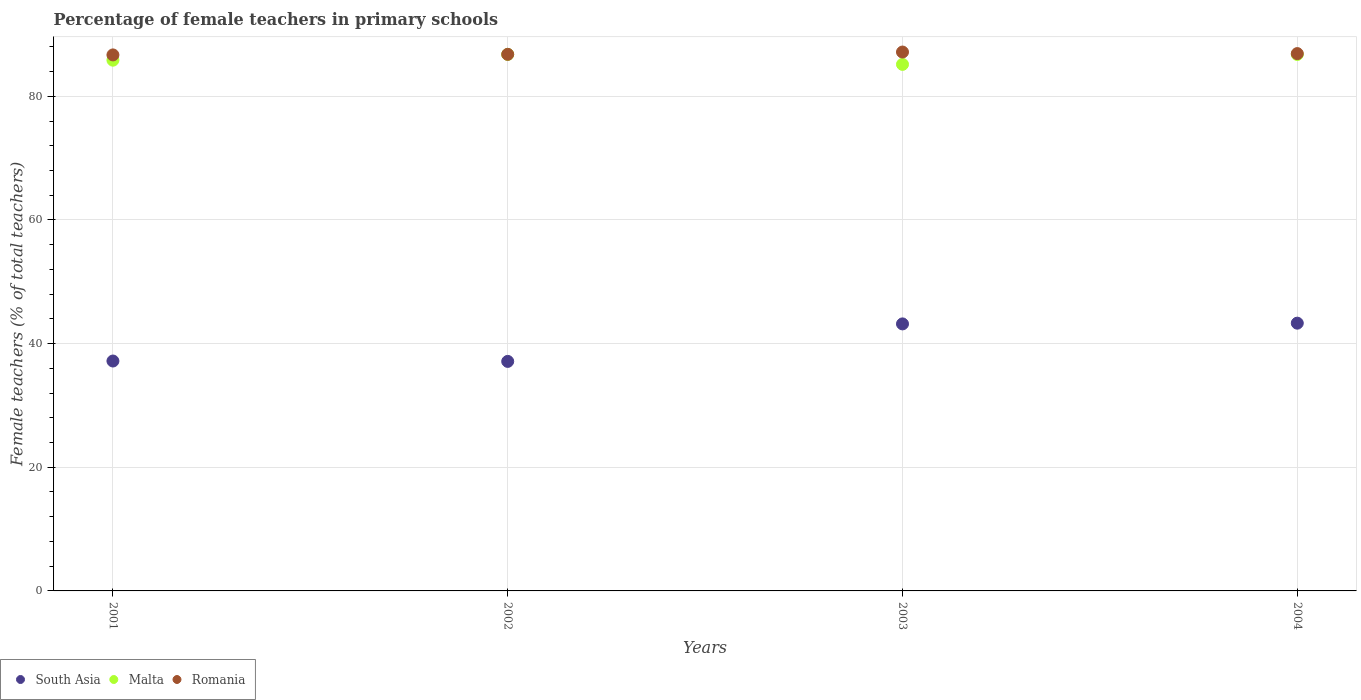Is the number of dotlines equal to the number of legend labels?
Give a very brief answer. Yes. What is the percentage of female teachers in Romania in 2002?
Your answer should be very brief. 86.78. Across all years, what is the maximum percentage of female teachers in Malta?
Keep it short and to the point. 86.77. Across all years, what is the minimum percentage of female teachers in Malta?
Keep it short and to the point. 85.16. In which year was the percentage of female teachers in South Asia maximum?
Offer a very short reply. 2004. In which year was the percentage of female teachers in Romania minimum?
Provide a succinct answer. 2001. What is the total percentage of female teachers in South Asia in the graph?
Your answer should be very brief. 160.79. What is the difference between the percentage of female teachers in Romania in 2001 and that in 2003?
Give a very brief answer. -0.46. What is the difference between the percentage of female teachers in Malta in 2004 and the percentage of female teachers in South Asia in 2001?
Your answer should be compact. 49.58. What is the average percentage of female teachers in Romania per year?
Provide a short and direct response. 86.88. In the year 2002, what is the difference between the percentage of female teachers in Malta and percentage of female teachers in Romania?
Provide a succinct answer. -0.01. What is the ratio of the percentage of female teachers in South Asia in 2002 to that in 2004?
Your answer should be very brief. 0.86. What is the difference between the highest and the second highest percentage of female teachers in Malta?
Offer a terse response. 0.01. What is the difference between the highest and the lowest percentage of female teachers in Romania?
Offer a terse response. 0.46. In how many years, is the percentage of female teachers in Malta greater than the average percentage of female teachers in Malta taken over all years?
Make the answer very short. 2. Is the sum of the percentage of female teachers in Malta in 2001 and 2002 greater than the maximum percentage of female teachers in Romania across all years?
Make the answer very short. Yes. Does the percentage of female teachers in South Asia monotonically increase over the years?
Keep it short and to the point. No. Is the percentage of female teachers in Malta strictly greater than the percentage of female teachers in Romania over the years?
Offer a very short reply. No. Is the percentage of female teachers in Malta strictly less than the percentage of female teachers in Romania over the years?
Provide a short and direct response. Yes. How many dotlines are there?
Keep it short and to the point. 3. What is the difference between two consecutive major ticks on the Y-axis?
Your answer should be compact. 20. Are the values on the major ticks of Y-axis written in scientific E-notation?
Provide a succinct answer. No. Does the graph contain any zero values?
Provide a short and direct response. No. Where does the legend appear in the graph?
Offer a very short reply. Bottom left. How many legend labels are there?
Your response must be concise. 3. What is the title of the graph?
Provide a short and direct response. Percentage of female teachers in primary schools. What is the label or title of the Y-axis?
Your answer should be compact. Female teachers (% of total teachers). What is the Female teachers (% of total teachers) in South Asia in 2001?
Provide a short and direct response. 37.18. What is the Female teachers (% of total teachers) of Malta in 2001?
Your response must be concise. 85.84. What is the Female teachers (% of total teachers) in Romania in 2001?
Your answer should be very brief. 86.69. What is the Female teachers (% of total teachers) of South Asia in 2002?
Ensure brevity in your answer.  37.12. What is the Female teachers (% of total teachers) of Malta in 2002?
Offer a terse response. 86.77. What is the Female teachers (% of total teachers) of Romania in 2002?
Provide a short and direct response. 86.78. What is the Female teachers (% of total teachers) in South Asia in 2003?
Your answer should be very brief. 43.19. What is the Female teachers (% of total teachers) of Malta in 2003?
Make the answer very short. 85.16. What is the Female teachers (% of total teachers) of Romania in 2003?
Offer a terse response. 87.15. What is the Female teachers (% of total teachers) of South Asia in 2004?
Make the answer very short. 43.3. What is the Female teachers (% of total teachers) of Malta in 2004?
Provide a succinct answer. 86.76. What is the Female teachers (% of total teachers) in Romania in 2004?
Keep it short and to the point. 86.9. Across all years, what is the maximum Female teachers (% of total teachers) of South Asia?
Your answer should be very brief. 43.3. Across all years, what is the maximum Female teachers (% of total teachers) in Malta?
Give a very brief answer. 86.77. Across all years, what is the maximum Female teachers (% of total teachers) of Romania?
Offer a terse response. 87.15. Across all years, what is the minimum Female teachers (% of total teachers) in South Asia?
Make the answer very short. 37.12. Across all years, what is the minimum Female teachers (% of total teachers) of Malta?
Make the answer very short. 85.16. Across all years, what is the minimum Female teachers (% of total teachers) in Romania?
Provide a succinct answer. 86.69. What is the total Female teachers (% of total teachers) of South Asia in the graph?
Your answer should be very brief. 160.79. What is the total Female teachers (% of total teachers) of Malta in the graph?
Offer a terse response. 344.52. What is the total Female teachers (% of total teachers) in Romania in the graph?
Provide a succinct answer. 347.53. What is the difference between the Female teachers (% of total teachers) in South Asia in 2001 and that in 2002?
Ensure brevity in your answer.  0.06. What is the difference between the Female teachers (% of total teachers) of Malta in 2001 and that in 2002?
Keep it short and to the point. -0.94. What is the difference between the Female teachers (% of total teachers) in Romania in 2001 and that in 2002?
Your answer should be very brief. -0.09. What is the difference between the Female teachers (% of total teachers) of South Asia in 2001 and that in 2003?
Keep it short and to the point. -6. What is the difference between the Female teachers (% of total teachers) in Malta in 2001 and that in 2003?
Give a very brief answer. 0.68. What is the difference between the Female teachers (% of total teachers) of Romania in 2001 and that in 2003?
Provide a succinct answer. -0.46. What is the difference between the Female teachers (% of total teachers) in South Asia in 2001 and that in 2004?
Your response must be concise. -6.12. What is the difference between the Female teachers (% of total teachers) of Malta in 2001 and that in 2004?
Keep it short and to the point. -0.92. What is the difference between the Female teachers (% of total teachers) in Romania in 2001 and that in 2004?
Make the answer very short. -0.21. What is the difference between the Female teachers (% of total teachers) in South Asia in 2002 and that in 2003?
Make the answer very short. -6.06. What is the difference between the Female teachers (% of total teachers) of Malta in 2002 and that in 2003?
Provide a short and direct response. 1.61. What is the difference between the Female teachers (% of total teachers) of Romania in 2002 and that in 2003?
Ensure brevity in your answer.  -0.37. What is the difference between the Female teachers (% of total teachers) of South Asia in 2002 and that in 2004?
Provide a short and direct response. -6.18. What is the difference between the Female teachers (% of total teachers) of Malta in 2002 and that in 2004?
Ensure brevity in your answer.  0.01. What is the difference between the Female teachers (% of total teachers) in Romania in 2002 and that in 2004?
Your response must be concise. -0.12. What is the difference between the Female teachers (% of total teachers) in South Asia in 2003 and that in 2004?
Provide a short and direct response. -0.12. What is the difference between the Female teachers (% of total teachers) in Malta in 2003 and that in 2004?
Give a very brief answer. -1.6. What is the difference between the Female teachers (% of total teachers) of Romania in 2003 and that in 2004?
Offer a terse response. 0.25. What is the difference between the Female teachers (% of total teachers) in South Asia in 2001 and the Female teachers (% of total teachers) in Malta in 2002?
Your answer should be very brief. -49.59. What is the difference between the Female teachers (% of total teachers) in South Asia in 2001 and the Female teachers (% of total teachers) in Romania in 2002?
Your answer should be compact. -49.6. What is the difference between the Female teachers (% of total teachers) of Malta in 2001 and the Female teachers (% of total teachers) of Romania in 2002?
Your response must be concise. -0.95. What is the difference between the Female teachers (% of total teachers) of South Asia in 2001 and the Female teachers (% of total teachers) of Malta in 2003?
Ensure brevity in your answer.  -47.98. What is the difference between the Female teachers (% of total teachers) in South Asia in 2001 and the Female teachers (% of total teachers) in Romania in 2003?
Your answer should be very brief. -49.97. What is the difference between the Female teachers (% of total teachers) of Malta in 2001 and the Female teachers (% of total teachers) of Romania in 2003?
Your response must be concise. -1.32. What is the difference between the Female teachers (% of total teachers) of South Asia in 2001 and the Female teachers (% of total teachers) of Malta in 2004?
Ensure brevity in your answer.  -49.58. What is the difference between the Female teachers (% of total teachers) in South Asia in 2001 and the Female teachers (% of total teachers) in Romania in 2004?
Provide a short and direct response. -49.72. What is the difference between the Female teachers (% of total teachers) of Malta in 2001 and the Female teachers (% of total teachers) of Romania in 2004?
Make the answer very short. -1.07. What is the difference between the Female teachers (% of total teachers) of South Asia in 2002 and the Female teachers (% of total teachers) of Malta in 2003?
Ensure brevity in your answer.  -48.04. What is the difference between the Female teachers (% of total teachers) of South Asia in 2002 and the Female teachers (% of total teachers) of Romania in 2003?
Give a very brief answer. -50.03. What is the difference between the Female teachers (% of total teachers) in Malta in 2002 and the Female teachers (% of total teachers) in Romania in 2003?
Provide a succinct answer. -0.38. What is the difference between the Female teachers (% of total teachers) of South Asia in 2002 and the Female teachers (% of total teachers) of Malta in 2004?
Give a very brief answer. -49.64. What is the difference between the Female teachers (% of total teachers) in South Asia in 2002 and the Female teachers (% of total teachers) in Romania in 2004?
Make the answer very short. -49.78. What is the difference between the Female teachers (% of total teachers) of Malta in 2002 and the Female teachers (% of total teachers) of Romania in 2004?
Offer a terse response. -0.13. What is the difference between the Female teachers (% of total teachers) in South Asia in 2003 and the Female teachers (% of total teachers) in Malta in 2004?
Keep it short and to the point. -43.57. What is the difference between the Female teachers (% of total teachers) in South Asia in 2003 and the Female teachers (% of total teachers) in Romania in 2004?
Your answer should be compact. -43.72. What is the difference between the Female teachers (% of total teachers) in Malta in 2003 and the Female teachers (% of total teachers) in Romania in 2004?
Offer a terse response. -1.74. What is the average Female teachers (% of total teachers) of South Asia per year?
Offer a very short reply. 40.2. What is the average Female teachers (% of total teachers) of Malta per year?
Offer a terse response. 86.13. What is the average Female teachers (% of total teachers) in Romania per year?
Keep it short and to the point. 86.88. In the year 2001, what is the difference between the Female teachers (% of total teachers) of South Asia and Female teachers (% of total teachers) of Malta?
Provide a succinct answer. -48.65. In the year 2001, what is the difference between the Female teachers (% of total teachers) in South Asia and Female teachers (% of total teachers) in Romania?
Make the answer very short. -49.51. In the year 2001, what is the difference between the Female teachers (% of total teachers) in Malta and Female teachers (% of total teachers) in Romania?
Your answer should be very brief. -0.85. In the year 2002, what is the difference between the Female teachers (% of total teachers) of South Asia and Female teachers (% of total teachers) of Malta?
Give a very brief answer. -49.65. In the year 2002, what is the difference between the Female teachers (% of total teachers) in South Asia and Female teachers (% of total teachers) in Romania?
Keep it short and to the point. -49.66. In the year 2002, what is the difference between the Female teachers (% of total teachers) of Malta and Female teachers (% of total teachers) of Romania?
Give a very brief answer. -0.01. In the year 2003, what is the difference between the Female teachers (% of total teachers) of South Asia and Female teachers (% of total teachers) of Malta?
Provide a succinct answer. -41.97. In the year 2003, what is the difference between the Female teachers (% of total teachers) in South Asia and Female teachers (% of total teachers) in Romania?
Offer a very short reply. -43.97. In the year 2003, what is the difference between the Female teachers (% of total teachers) in Malta and Female teachers (% of total teachers) in Romania?
Ensure brevity in your answer.  -2. In the year 2004, what is the difference between the Female teachers (% of total teachers) in South Asia and Female teachers (% of total teachers) in Malta?
Your answer should be compact. -43.45. In the year 2004, what is the difference between the Female teachers (% of total teachers) of South Asia and Female teachers (% of total teachers) of Romania?
Provide a succinct answer. -43.6. In the year 2004, what is the difference between the Female teachers (% of total teachers) in Malta and Female teachers (% of total teachers) in Romania?
Offer a very short reply. -0.14. What is the ratio of the Female teachers (% of total teachers) in South Asia in 2001 to that in 2003?
Your response must be concise. 0.86. What is the ratio of the Female teachers (% of total teachers) of Romania in 2001 to that in 2003?
Ensure brevity in your answer.  0.99. What is the ratio of the Female teachers (% of total teachers) in South Asia in 2001 to that in 2004?
Give a very brief answer. 0.86. What is the ratio of the Female teachers (% of total teachers) of South Asia in 2002 to that in 2003?
Provide a short and direct response. 0.86. What is the ratio of the Female teachers (% of total teachers) of Malta in 2002 to that in 2003?
Your answer should be very brief. 1.02. What is the ratio of the Female teachers (% of total teachers) in South Asia in 2002 to that in 2004?
Offer a very short reply. 0.86. What is the ratio of the Female teachers (% of total teachers) of Romania in 2002 to that in 2004?
Give a very brief answer. 1. What is the ratio of the Female teachers (% of total teachers) of South Asia in 2003 to that in 2004?
Give a very brief answer. 1. What is the ratio of the Female teachers (% of total teachers) in Malta in 2003 to that in 2004?
Give a very brief answer. 0.98. What is the ratio of the Female teachers (% of total teachers) in Romania in 2003 to that in 2004?
Keep it short and to the point. 1. What is the difference between the highest and the second highest Female teachers (% of total teachers) of South Asia?
Ensure brevity in your answer.  0.12. What is the difference between the highest and the second highest Female teachers (% of total teachers) in Malta?
Provide a short and direct response. 0.01. What is the difference between the highest and the second highest Female teachers (% of total teachers) of Romania?
Your response must be concise. 0.25. What is the difference between the highest and the lowest Female teachers (% of total teachers) of South Asia?
Your answer should be very brief. 6.18. What is the difference between the highest and the lowest Female teachers (% of total teachers) in Malta?
Your response must be concise. 1.61. What is the difference between the highest and the lowest Female teachers (% of total teachers) in Romania?
Provide a succinct answer. 0.46. 